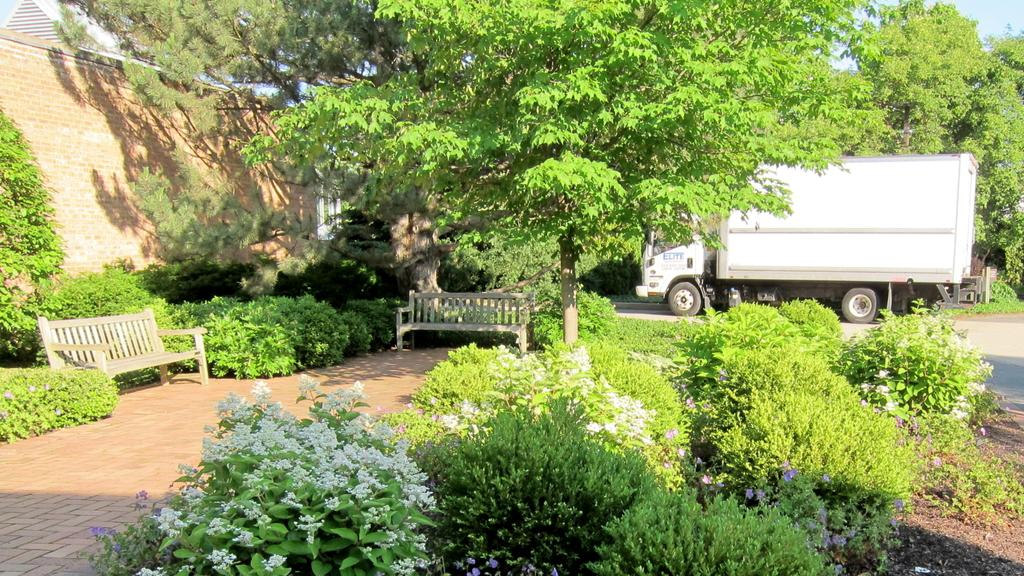What is the main subject of the image? The main subject of the image is a truck. What type of natural elements can be seen in the image? There are trees in the image. What type of seating is present in the image? There are benches in the image. What type of plants are visible in the image? There are plants with flowers in the image. Can you tell me how many volleyballs are visible in the image? There are no volleyballs present in the image. What type of zipper can be seen on the truck in the image? There is no zipper present on the truck in the image. What type of hose is connected to the truck in the image? There is no hose connected to the truck in the image. 